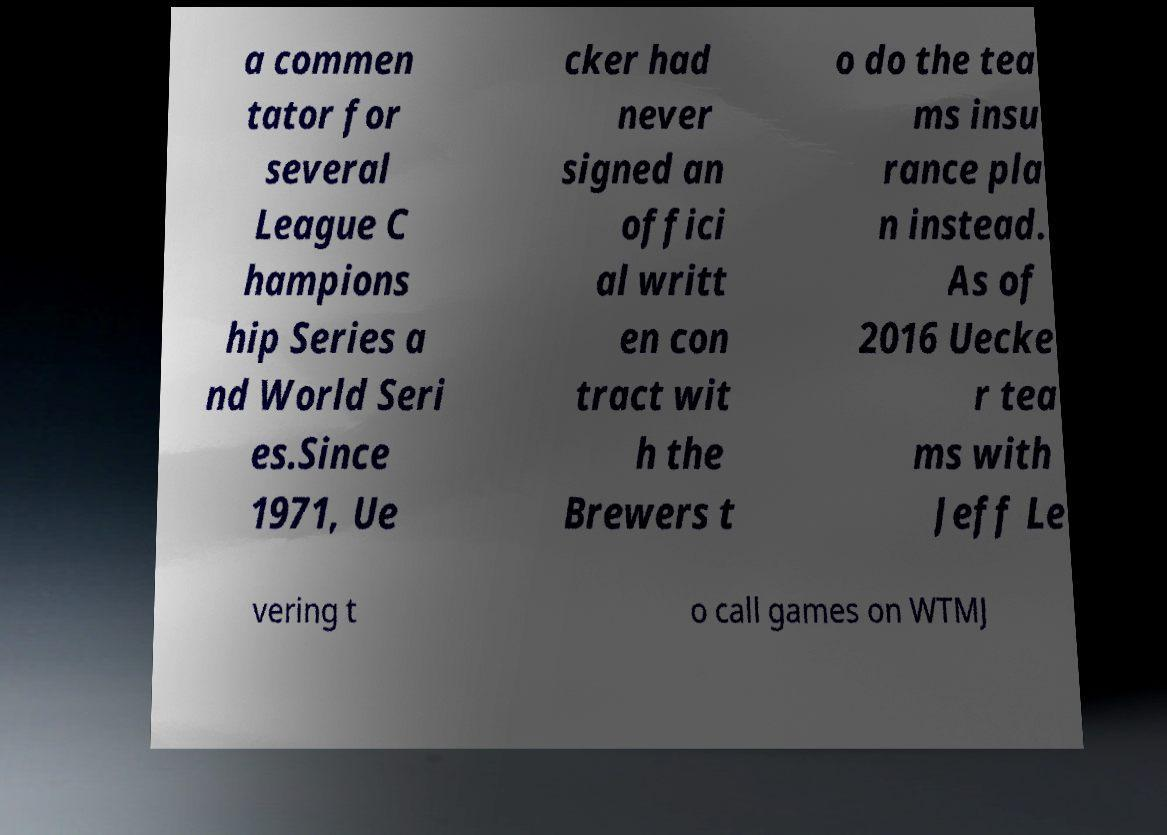I need the written content from this picture converted into text. Can you do that? a commen tator for several League C hampions hip Series a nd World Seri es.Since 1971, Ue cker had never signed an offici al writt en con tract wit h the Brewers t o do the tea ms insu rance pla n instead. As of 2016 Uecke r tea ms with Jeff Le vering t o call games on WTMJ 